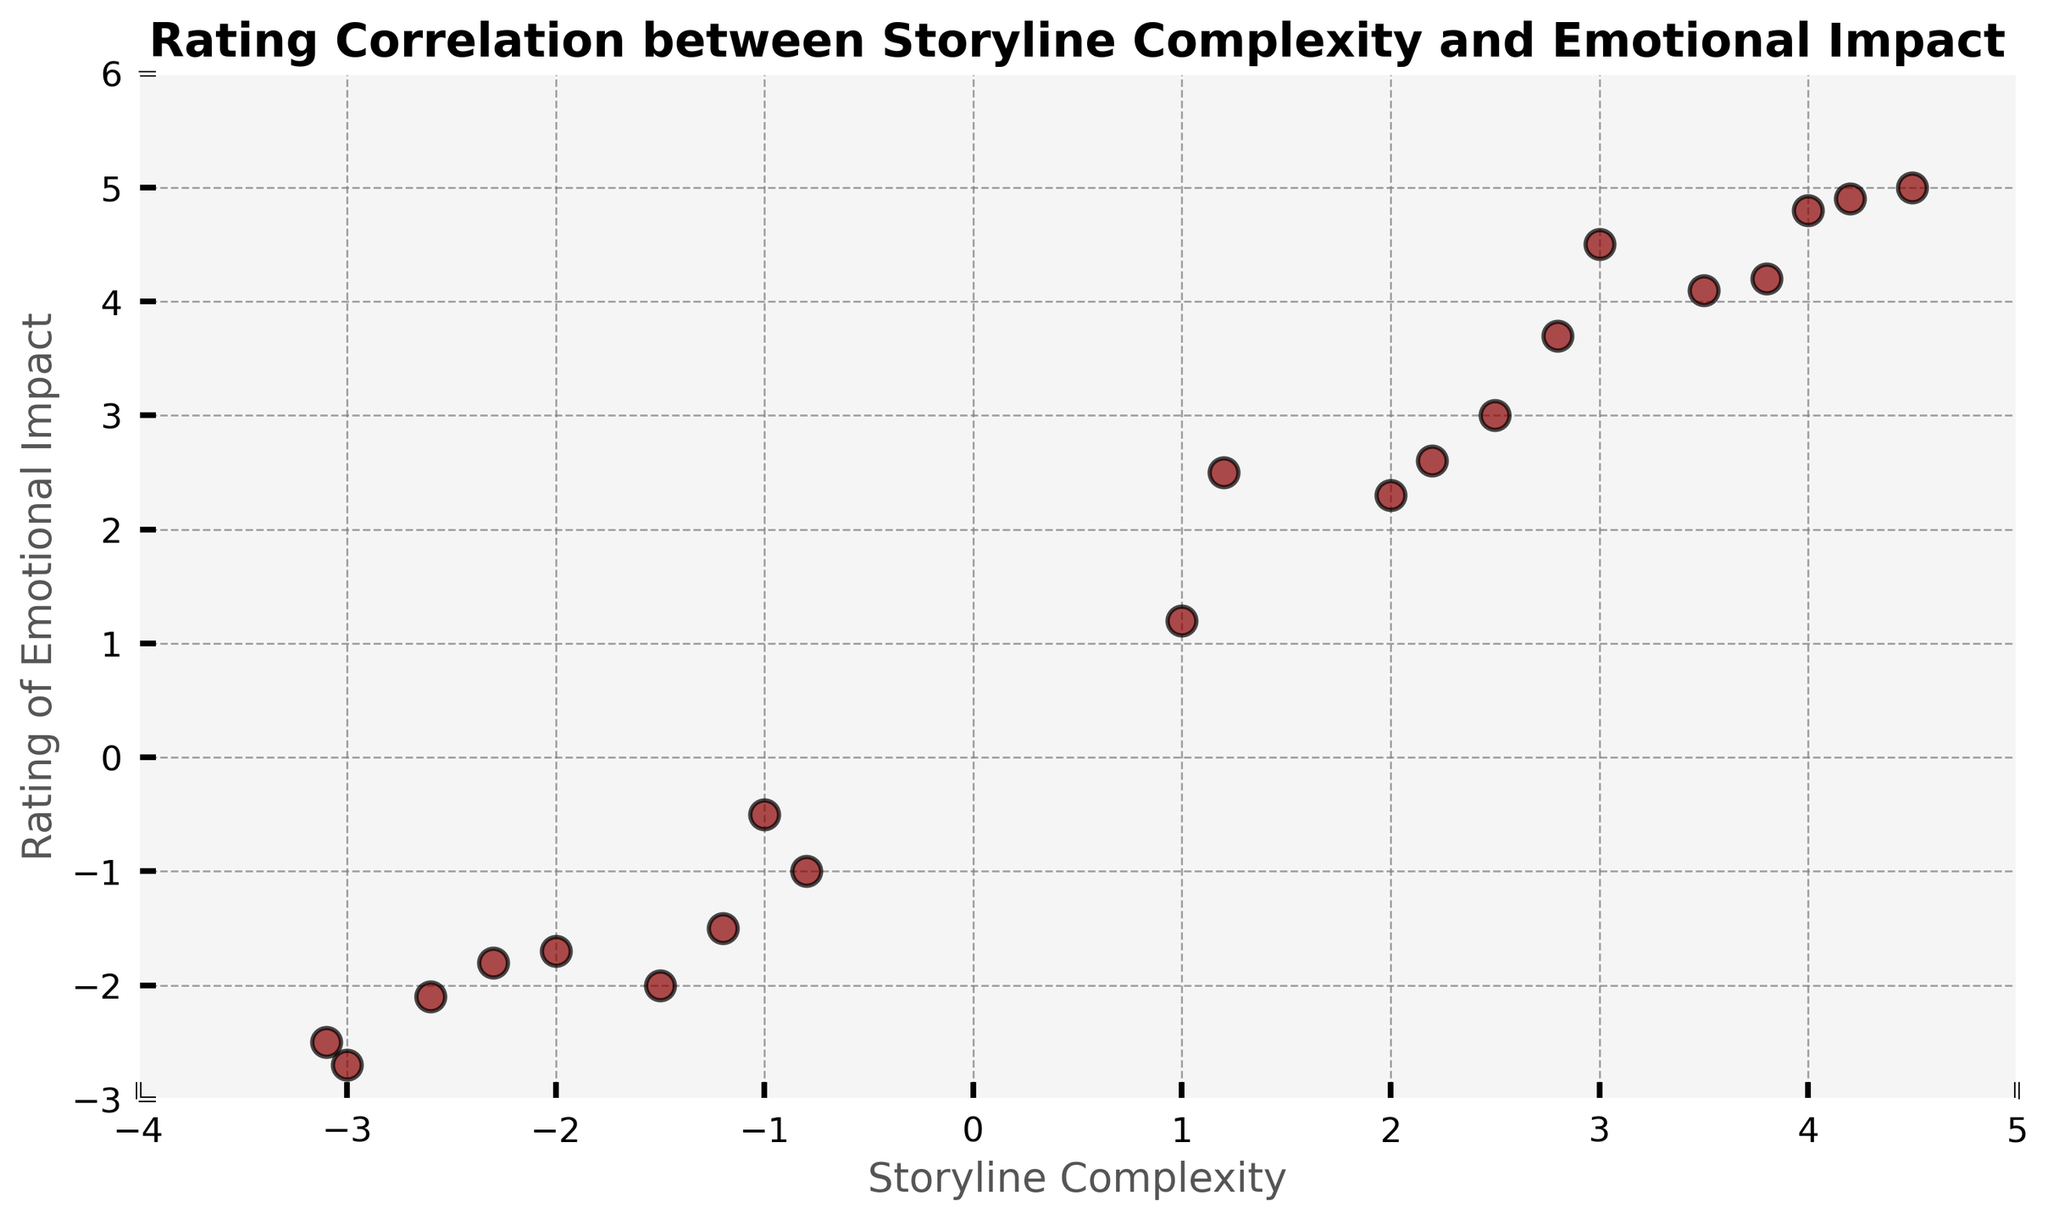what is the relationship between storyline complexity and emotional impact in tragic love story graphic novels? To determine the relationship, you can observe the overall trend in the scatter plot. Most data points appear to follow a positive linear trend, where higher storyline complexity correlates with higher emotional impact, and lower storyline complexity correlates with lower emotional impact. Therefore, it seems that more complex storylines generally tend to have a higher emotional impact.
Answer: Positive correlation What is the emotional impact rating for the graphic novel with the highest storyline complexity? To find this, look for the highest value on the x-axis (storyline complexity) which is 4.5. The corresponding y-axis value (emotional impact rating) for this data point is 5.0.
Answer: 5.0 How many graphic novels have a negative emotional impact rating? Count the number of data points that are below 0 on the y-axis. There are 7 data points where the emotional impact rating is negative.
Answer: 7 Which data point has the closest values between storyline complexity and emotional impact? Look for a data point where the x and y values are most similar. The data point (3.0, 4.5) is closest, as the difference between the values is minimal.
Answer: (3.0, 4.5) What is the range of storyline complexity values? To find the range, identify the minimum and maximum storyline complexity values. The minimum complexity is -3.1 and the maximum complexity is 4.5. The range is 4.5 - (-3.1) = 7.6.
Answer: 7.6 Which graphic novel has the lowest emotional impact rating? Look for the lowest value on the y-axis, which is -2.7. The corresponding data point is (-3.0, -2.7).
Answer: -2.7 Are there more graphic novels with positive or negative storyline complexity values? Count the data points with positive and negative storyline complexity. There are 11 data points with positive values and 9 with negative values, so there are more with positive storyline complexity.
Answer: Positive (11) What is the average rating of emotional impact for graphic novels with positive storyline complexity? Add the emotional impact ratings for positive storyline complexity: 2.5 + 3.7 + 4.5 + 5.0 + 3.0 + 1.2 + 2.3 + 4.1 + 4.8 + 2.6 + 4.2 = 37.9. Divide by the number of data points, which is 11: 37.9 / 11 = 3.445.
Answer: 3.445 Does the plotted data show any outliers where storyline complexity and emotional impact ratings are vastly different compared to the general trend? An outlier would be a point that significantly deviates from the trend line. Observing the plot, the point (-3.0, -2.7) appears significantly lower compared to other points with similar storyline complexities, indicating possible outliers.
Answer: Yes, (-3.0, -2.7) 